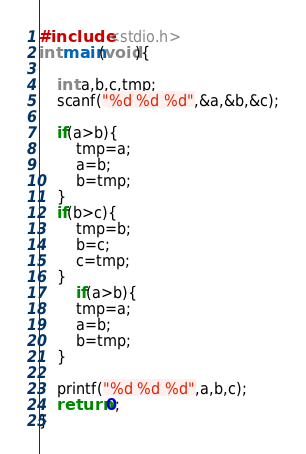<code> <loc_0><loc_0><loc_500><loc_500><_C_>#include <stdio.h>
int main(void){
    
    int a,b,c,tmp;
    scanf("%d %d %d",&a,&b,&c);

    if(a>b){
        tmp=a;
        a=b;
        b=tmp;
    }
    if(b>c){
        tmp=b;
        b=c;
        c=tmp;
    }
        if(a>b){
        tmp=a;
        a=b;
        b=tmp;
    }
    
    printf("%d %d %d",a,b,c);
    return 0;
}

</code> 